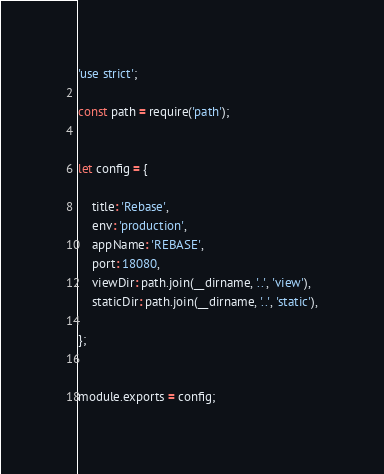<code> <loc_0><loc_0><loc_500><loc_500><_JavaScript_>'use strict';

const path = require('path');


let config = {

    title: 'Rebase',
    env: 'production',
    appName: 'REBASE',
    port: 18080,
    viewDir: path.join(__dirname, '..', 'view'),
    staticDir: path.join(__dirname, '..', 'static'),

};


module.exports = config;
</code> 